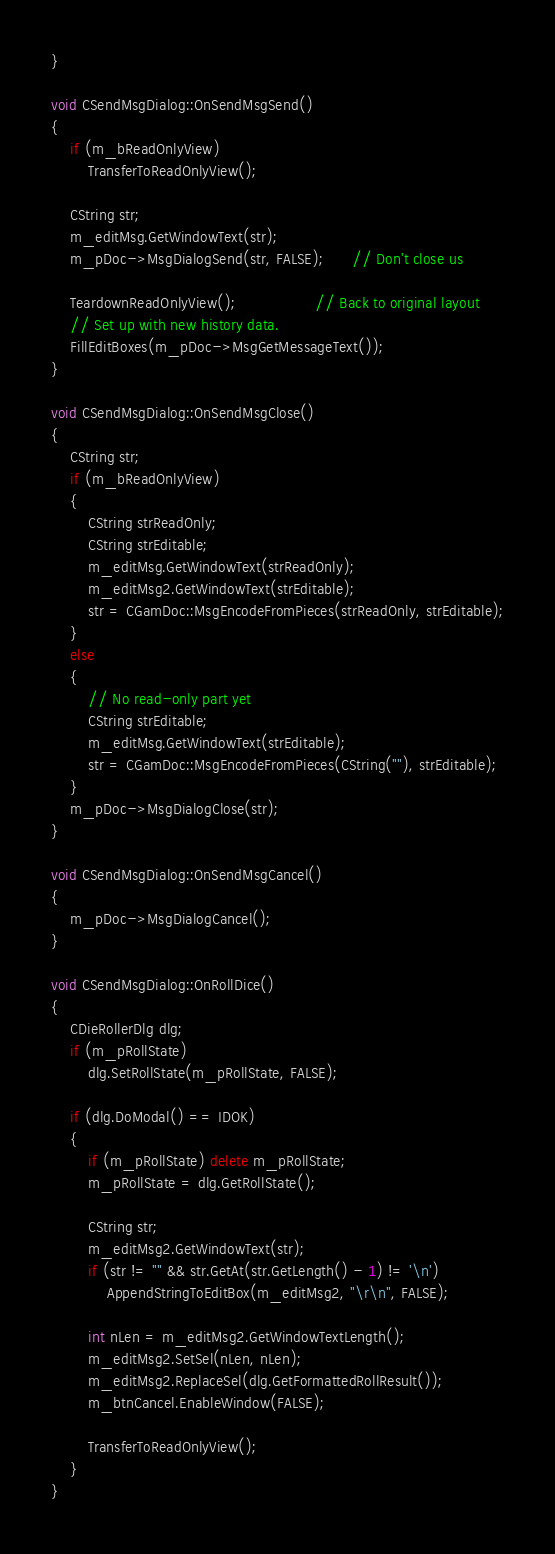Convert code to text. <code><loc_0><loc_0><loc_500><loc_500><_C++_>}

void CSendMsgDialog::OnSendMsgSend()
{
    if (m_bReadOnlyView)
        TransferToReadOnlyView();

    CString str;
    m_editMsg.GetWindowText(str);
    m_pDoc->MsgDialogSend(str, FALSE);      // Don't close us

    TeardownReadOnlyView();                 // Back to original layout
    // Set up with new history data.
    FillEditBoxes(m_pDoc->MsgGetMessageText());
}

void CSendMsgDialog::OnSendMsgClose()
{
    CString str;
    if (m_bReadOnlyView)
    {
        CString strReadOnly;
        CString strEditable;
        m_editMsg.GetWindowText(strReadOnly);
        m_editMsg2.GetWindowText(strEditable);
        str = CGamDoc::MsgEncodeFromPieces(strReadOnly, strEditable);
    }
    else
    {
        // No read-only part yet
        CString strEditable;
        m_editMsg.GetWindowText(strEditable);
        str = CGamDoc::MsgEncodeFromPieces(CString(""), strEditable);
    }
    m_pDoc->MsgDialogClose(str);
}

void CSendMsgDialog::OnSendMsgCancel()
{
    m_pDoc->MsgDialogCancel();
}

void CSendMsgDialog::OnRollDice()
{
    CDieRollerDlg dlg;
    if (m_pRollState)
        dlg.SetRollState(m_pRollState, FALSE);

    if (dlg.DoModal() == IDOK)
    {
        if (m_pRollState) delete m_pRollState;
        m_pRollState = dlg.GetRollState();

        CString str;
        m_editMsg2.GetWindowText(str);
        if (str != "" && str.GetAt(str.GetLength() - 1) != '\n')
            AppendStringToEditBox(m_editMsg2, "\r\n", FALSE);

        int nLen = m_editMsg2.GetWindowTextLength();
        m_editMsg2.SetSel(nLen, nLen);
        m_editMsg2.ReplaceSel(dlg.GetFormattedRollResult());
        m_btnCancel.EnableWindow(FALSE);

        TransferToReadOnlyView();
    }
}


</code> 